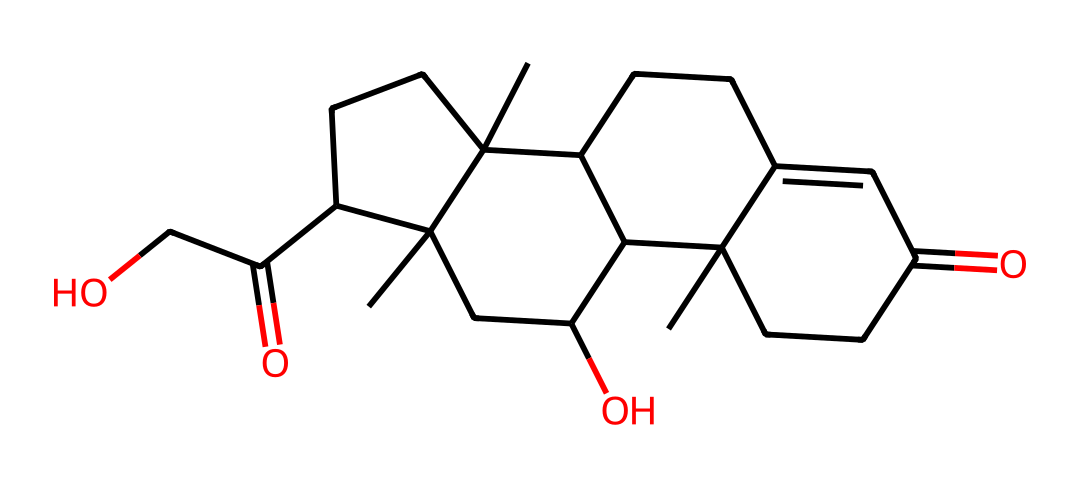what is the molecular formula of this chemical? To determine the molecular formula, we count the number of each type of atom in the chemical structure. Analyzing the SMILES representation reveals that there are 21 carbon atoms, 30 hydrogen atoms, and 5 oxygen atoms. Therefore, the molecular formula is C21H30O5.
Answer: C21H30O5 how many rings are present in the molecular structure? By examining the chemical structure derived from the SMILES, we can identify the presence of multiple ring structures. The numbering of atoms in the SMILES indicates there are 4 rings in total.
Answer: 4 what type of hormone is represented by this structure? Based on its chemical structure and classification, this compound is identified as a steroid hormone. This is due to its characteristic arrangement of carbon atoms forming fused rings.
Answer: steroid how many oxygen atoms are in the structure? From the molecular formula breakdown, we can see that there are 5 oxygen atoms present in the chemical structure. Counting directly from the structure confirms this count as well.
Answer: 5 what functional groups can be identified in the molecule? Analyzing the chemical structure shows the presence of carbonyl groups (C=O) due to the two ketone functional groups it contains in the cyclic framework. This functionality is important for its biochemical activity.
Answer: carbonyl groups how does the structure relate to stress response? The arrangement of carbon atoms and specific functional groups, particularly the steroid backbone, gives this hormone properties that allow it to regulate metabolism and the stress response in the body. Thus, it is crucial for handling stress.
Answer: regulates stress response 